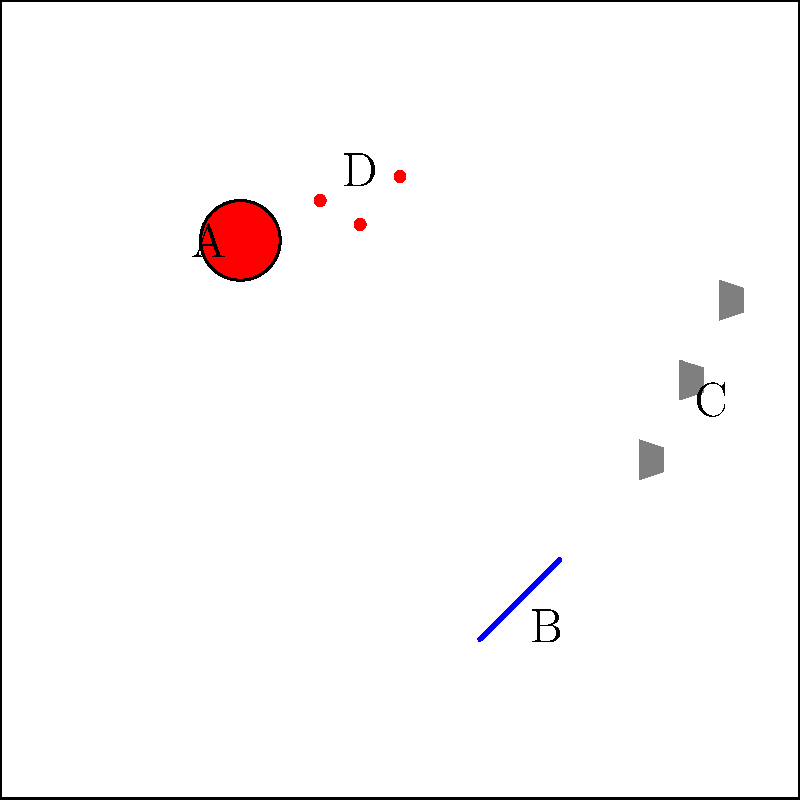In the crime scene diagram above, which piece of evidence is most likely to provide crucial information about the perpetrator's identity and movements? To identify the key evidence in this crime scene photograph, let's analyze each element:

1. Victim (A): While important, the victim's position alone doesn't provide direct information about the perpetrator's identity or movements.

2. Weapon (B): The weapon is crucial evidence, but it may not directly reveal the perpetrator's identity or movements without further analysis.

3. Footprints (C): These are the most valuable piece of evidence in this scenario because:
   a) They show the perpetrator's movement pattern within the crime scene.
   b) They can potentially reveal the perpetrator's shoe size and type.
   c) They may contain trace evidence from the perpetrator's last location.
   d) They can be used to match against a suspect's shoes or gait analysis.

4. Blood spatter (D): While important for understanding the crime's nature, it doesn't directly identify the perpetrator or their movements.

In a criminal trial, footprints are often considered strong physical evidence that can link a suspect to the crime scene. They provide a tangible connection between the perpetrator and the location, which is crucial for both prosecution and defense arguments.
Answer: Footprints (C) 